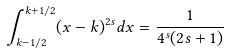Convert formula to latex. <formula><loc_0><loc_0><loc_500><loc_500>\int _ { k - 1 / 2 } ^ { k + 1 / 2 } ( x - k ) ^ { 2 s } d x = \frac { 1 } { 4 ^ { s } ( 2 s + 1 ) }</formula> 